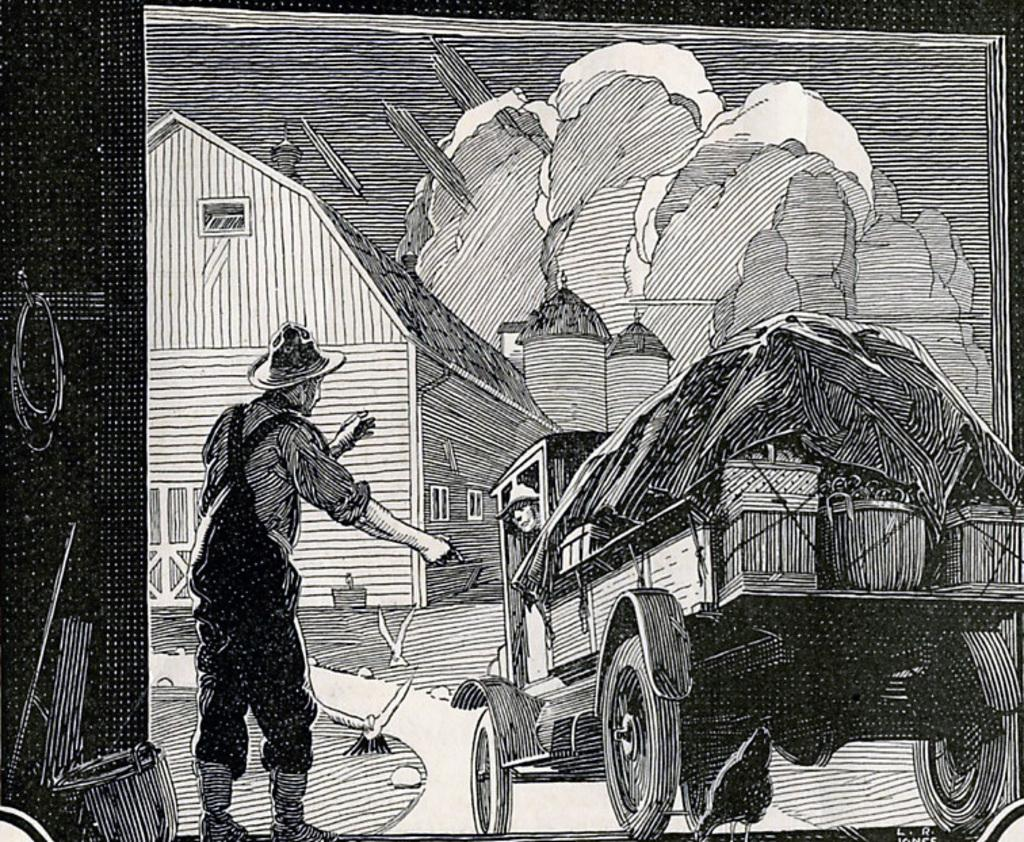What is parked on the road in the image? There is a vehicle parked on the road in the image. Can you describe the person standing in the image? The person is standing to the left side of the image and is wearing a hat. What can be seen in the background of the image? There is a building and the sky visible in the background of the image. What type of glue is the person using to fix the wound on their hand in the image? There is no person with a wound or using glue in the image. 